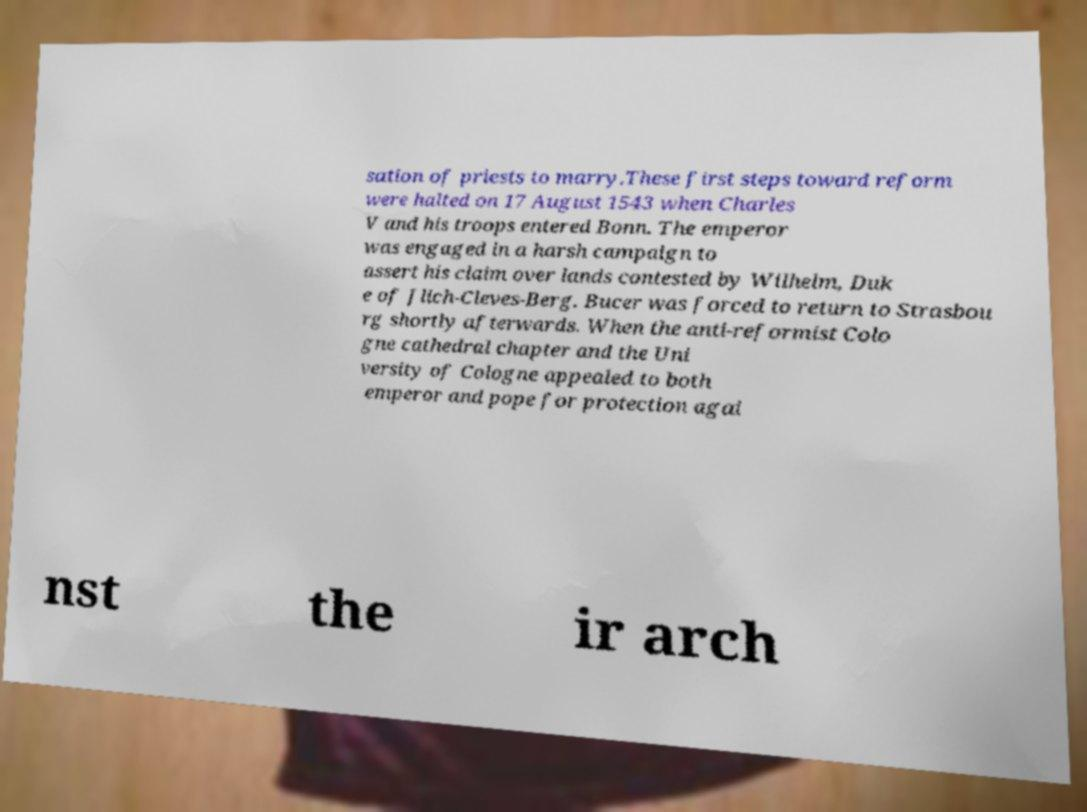What messages or text are displayed in this image? I need them in a readable, typed format. sation of priests to marry.These first steps toward reform were halted on 17 August 1543 when Charles V and his troops entered Bonn. The emperor was engaged in a harsh campaign to assert his claim over lands contested by Wilhelm, Duk e of Jlich-Cleves-Berg. Bucer was forced to return to Strasbou rg shortly afterwards. When the anti-reformist Colo gne cathedral chapter and the Uni versity of Cologne appealed to both emperor and pope for protection agai nst the ir arch 